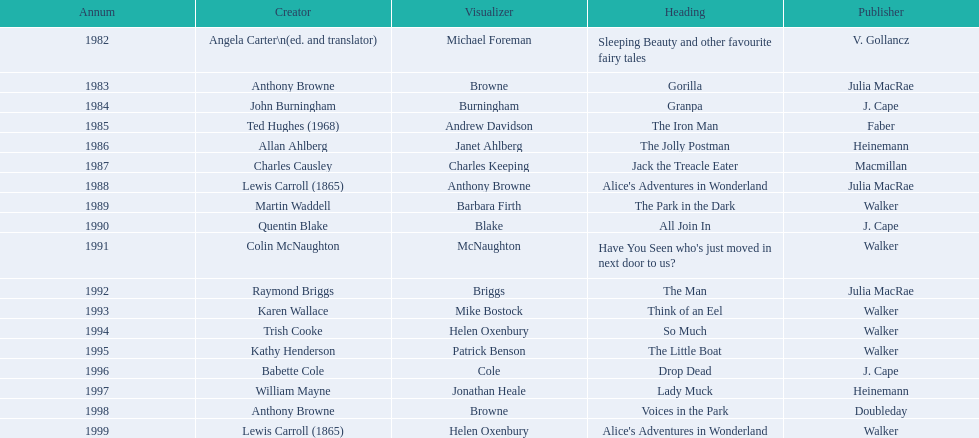Which author wrote the first award winner? Angela Carter. 